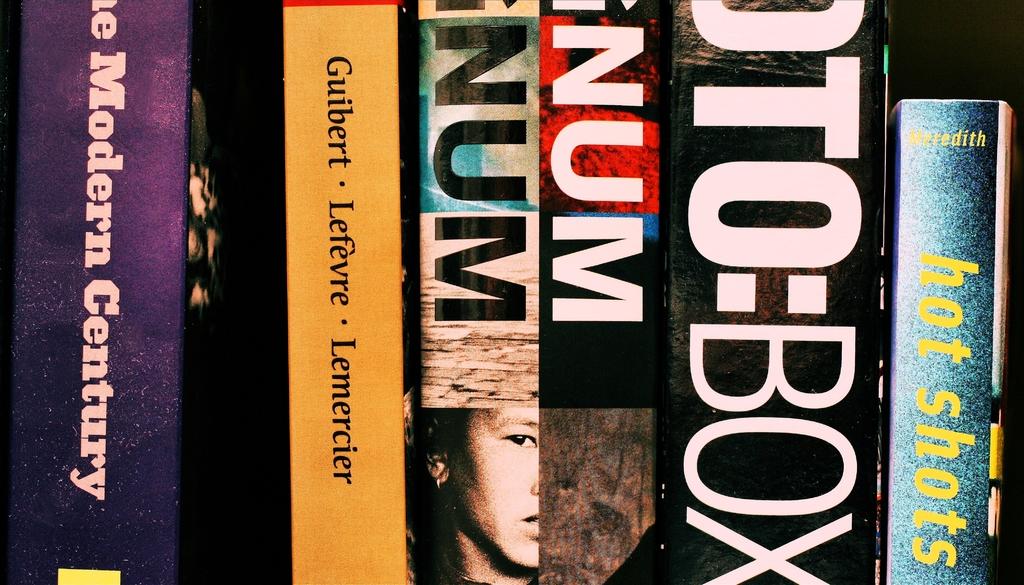What author(s) is/are listed on the yellow book?
Offer a terse response. Guibert, lefevre, lemercier. 